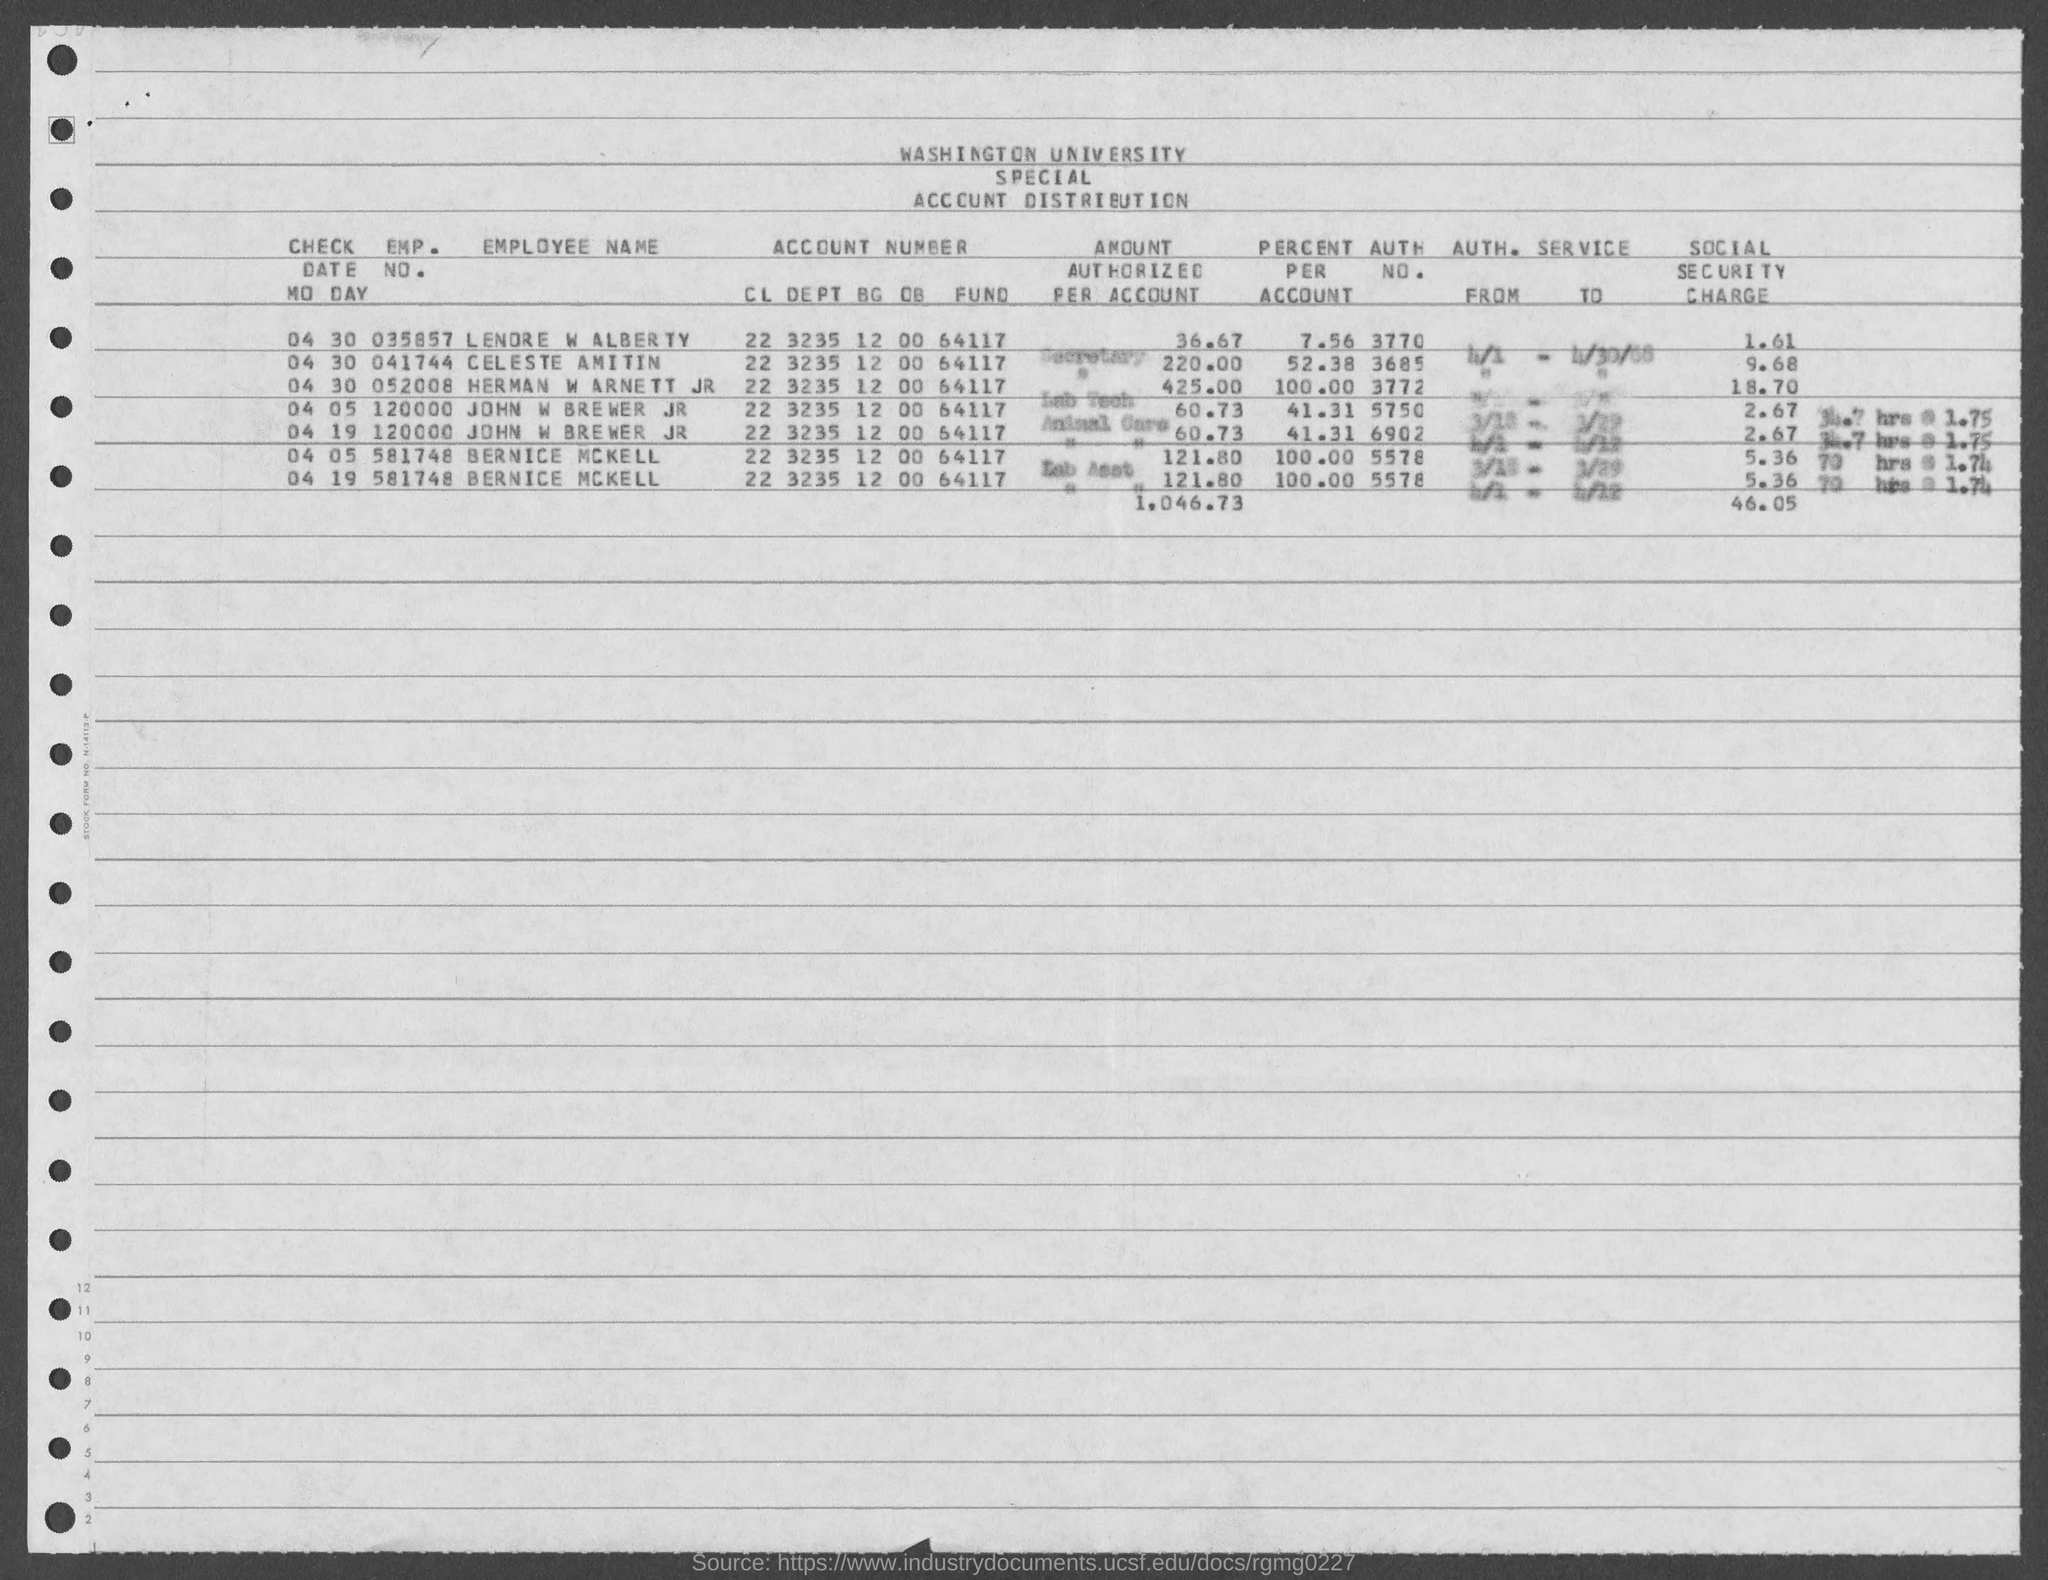What is the employee no. of lendre w alber tv?
Offer a terse response. 035857. What is the Account Number of BERNICE MCKELL?
Provide a short and direct response. 22 3235 12 00 64117. 